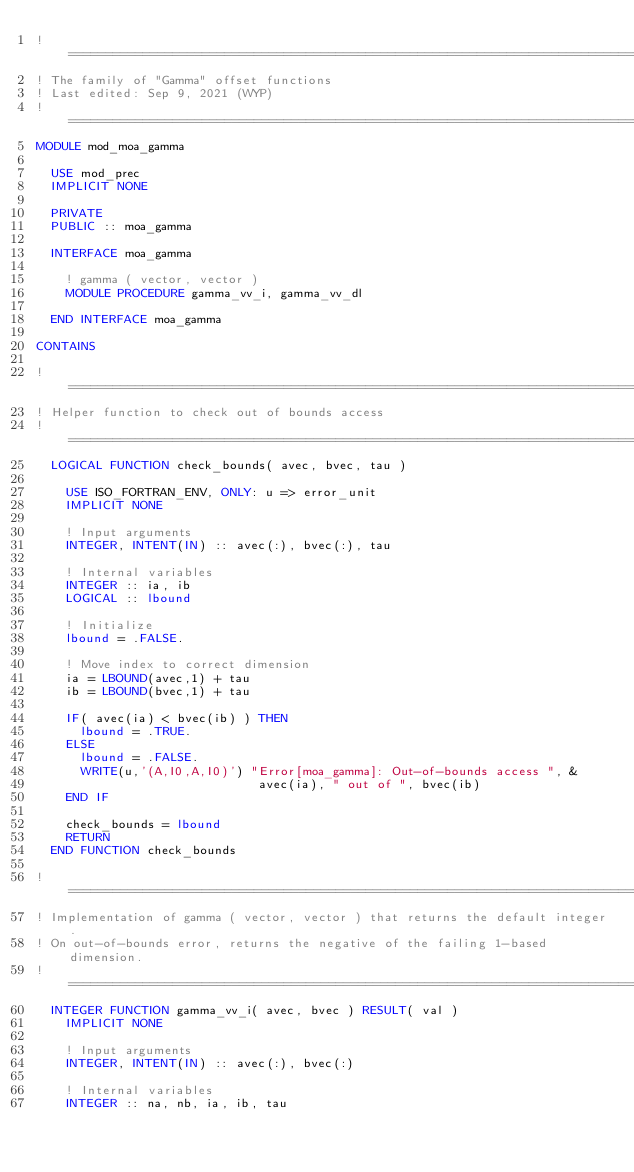<code> <loc_0><loc_0><loc_500><loc_500><_FORTRAN_>!===============================================================================
! The family of "Gamma" offset functions
! Last edited: Sep 9, 2021 (WYP)
!===============================================================================
MODULE mod_moa_gamma

  USE mod_prec
  IMPLICIT NONE

  PRIVATE
  PUBLIC :: moa_gamma

  INTERFACE moa_gamma

    ! gamma ( vector, vector )
    MODULE PROCEDURE gamma_vv_i, gamma_vv_dl

  END INTERFACE moa_gamma

CONTAINS

!===============================================================================
! Helper function to check out of bounds access
!===============================================================================
  LOGICAL FUNCTION check_bounds( avec, bvec, tau )

    USE ISO_FORTRAN_ENV, ONLY: u => error_unit
    IMPLICIT NONE

    ! Input arguments
    INTEGER, INTENT(IN) :: avec(:), bvec(:), tau

    ! Internal variables
    INTEGER :: ia, ib
    LOGICAL :: lbound

    ! Initialize
    lbound = .FALSE.

    ! Move index to correct dimension
    ia = LBOUND(avec,1) + tau
    ib = LBOUND(bvec,1) + tau

    IF( avec(ia) < bvec(ib) ) THEN
      lbound = .TRUE.
    ELSE
      lbound = .FALSE.
      WRITE(u,'(A,I0,A,I0)') "Error[moa_gamma]: Out-of-bounds access ", &
                              avec(ia), " out of ", bvec(ib)
    END IF

    check_bounds = lbound
    RETURN
  END FUNCTION check_bounds

!===============================================================================
! Implementation of gamma ( vector, vector ) that returns the default integer.
! On out-of-bounds error, returns the negative of the failing 1-based dimension.
!===============================================================================
  INTEGER FUNCTION gamma_vv_i( avec, bvec ) RESULT( val )
    IMPLICIT NONE

    ! Input arguments
    INTEGER, INTENT(IN) :: avec(:), bvec(:)

    ! Internal variables
    INTEGER :: na, nb, ia, ib, tau</code> 